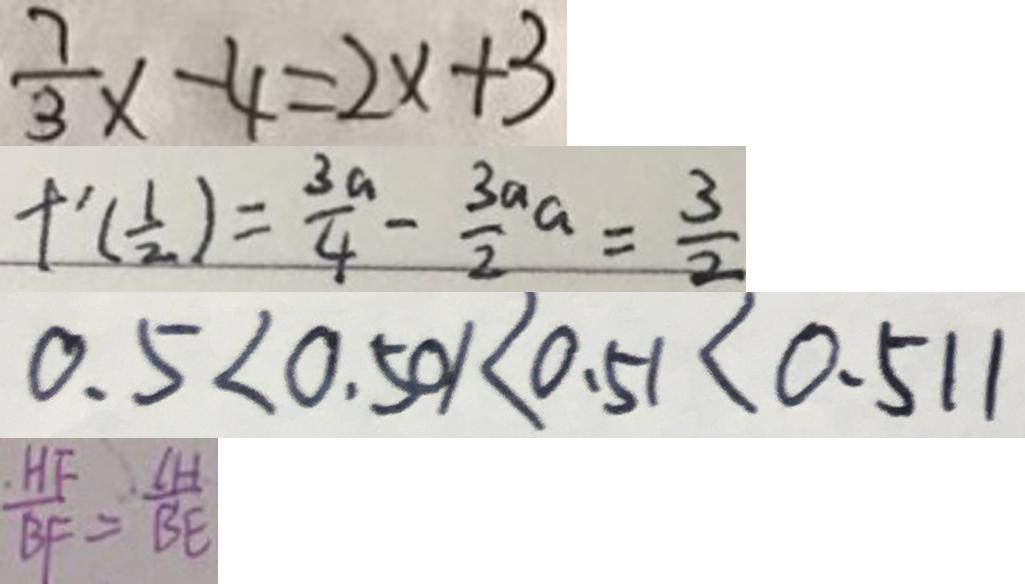Convert formula to latex. <formula><loc_0><loc_0><loc_500><loc_500>\frac { 7 } { 3 } x - 4 = 2 x + 3 
 f ^ { \prime } ( \frac { 1 } { 2 } ) = \frac { 3 a } { 4 } - \frac { 3 a } { 2 } a = \frac { 3 } { 2 } 
 0 . 5 < 0 . 5 0 1 < 0 . 5 1 < 0 . 5 1 1 
 \frac { H F } { B F } = \frac { \vert C H \vert } { B E }</formula> 